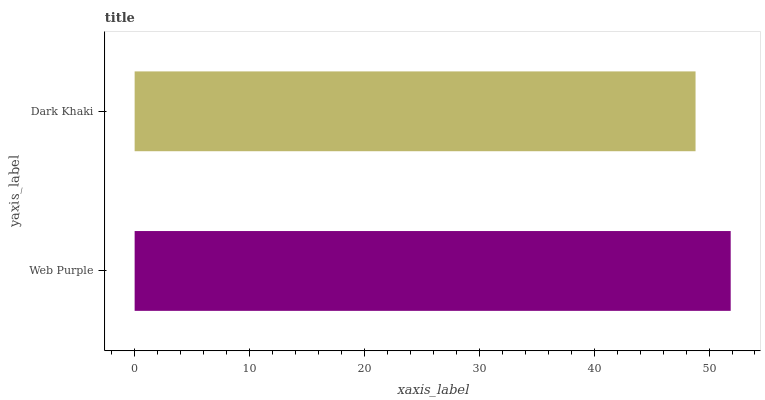Is Dark Khaki the minimum?
Answer yes or no. Yes. Is Web Purple the maximum?
Answer yes or no. Yes. Is Dark Khaki the maximum?
Answer yes or no. No. Is Web Purple greater than Dark Khaki?
Answer yes or no. Yes. Is Dark Khaki less than Web Purple?
Answer yes or no. Yes. Is Dark Khaki greater than Web Purple?
Answer yes or no. No. Is Web Purple less than Dark Khaki?
Answer yes or no. No. Is Web Purple the high median?
Answer yes or no. Yes. Is Dark Khaki the low median?
Answer yes or no. Yes. Is Dark Khaki the high median?
Answer yes or no. No. Is Web Purple the low median?
Answer yes or no. No. 